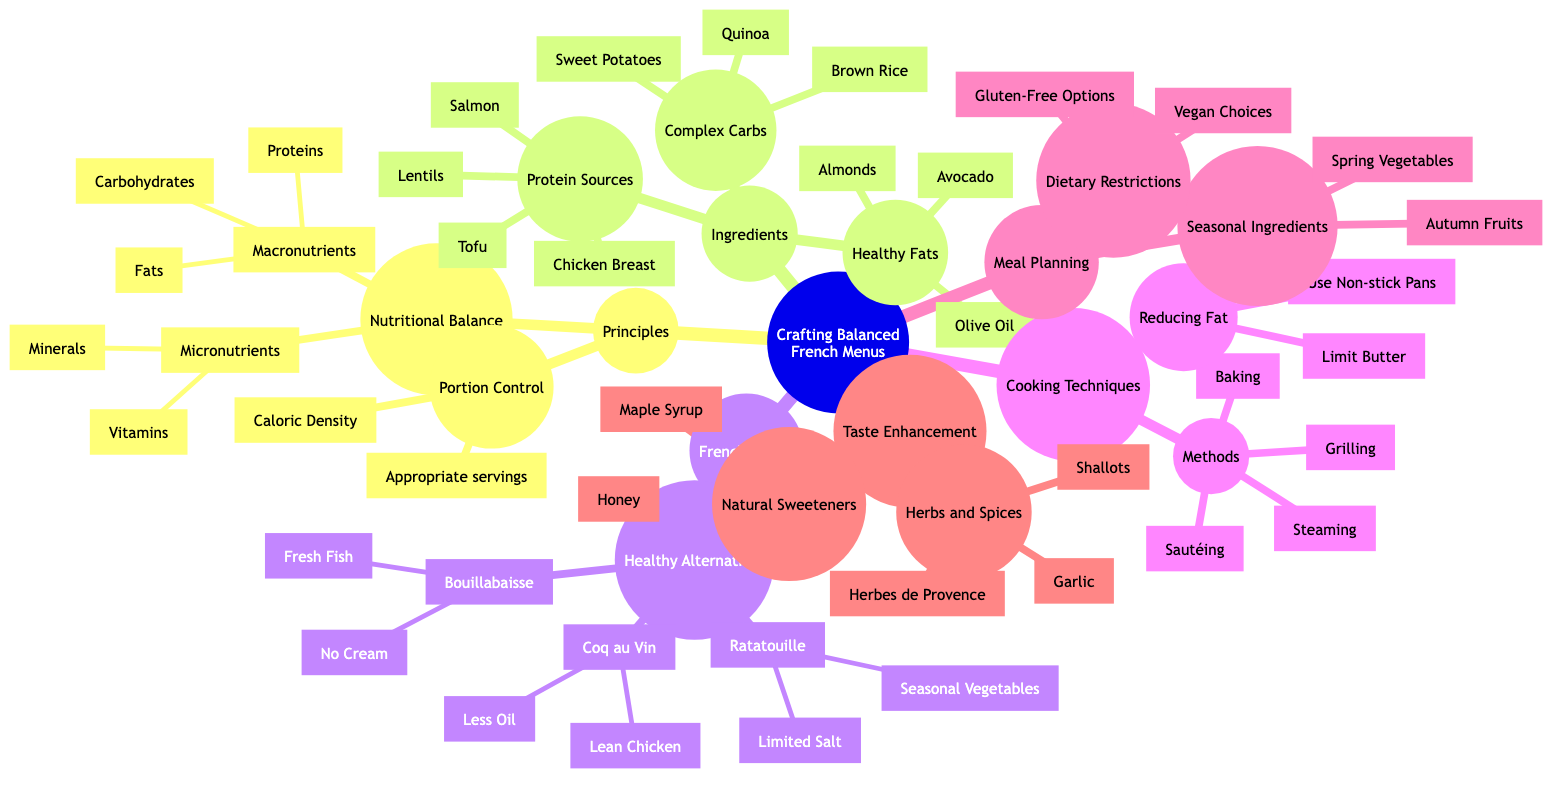What are the two types of nutrients listed under Nutritional Balance? The diagram specifies two categories of nutrients under Nutritional Balance: Macronutrients and Micronutrients. These are the explicit titles shown, indicating the separation between the types of nutrients.
Answer: Macronutrients, Micronutrients How many cooking methods are mentioned? Under the Cooking Techniques section, the Methods can be counted, which include Steaming, Grilling, Sautéing, and Baking, totaling four different methods.
Answer: 4 What is a healthy alternative for Coq au Vin? The Healthy Alternatives for Coq au Vin is listed, showing that one of the suggested modifications is using Less Oil. This indicates a specific change from the original recipe to make it healthier.
Answer: Less Oil Which protein sources are plant-based? In the Protein Sources section, Lentils and Tofu are indicated as the plant-based protein options. This requires identifying which items are categorized as plant-based from the list provided.
Answer: Lentils, Tofu Which healthy fat is listed that comes from a fruit? Among the Healthy Fats, Avocado is noted as a fat source that comes specifically from a fruit. This requires recognizing Avocado from the list of healthy fats since it is botanically classified as a fruit.
Answer: Avocado What cooking technique is suggested to reduce fat? The diagram mentions "Use Non-stick Pans" as a method to reduce fat within the Cooking Techniques section, indicating practical advice to lower fat content in meals.
Answer: Use Non-stick Pans What meal planning option addresses dietary restrictions? Under Meal Planning, "Dietary Restrictions" indicates options such as Gluten-Free Options and Vegan Choices. Recognizing that these are modifications to accommodate dietary needs leads to the answer.
Answer: Gluten-Free Options, Vegan Choices How many types of micronutrients are listed? The micronutrients section includes two types: Vitamins and Minerals, thus requiring a count of the listed items to determine the total number of types.
Answer: 2 What are the natural sweeteners mentioned in the diagram? The Taste Enhancement section indicates two natural sweeteners: Honey and Maple Syrup. This involves listing the items directly mentioned under that category.
Answer: Honey, Maple Syrup 